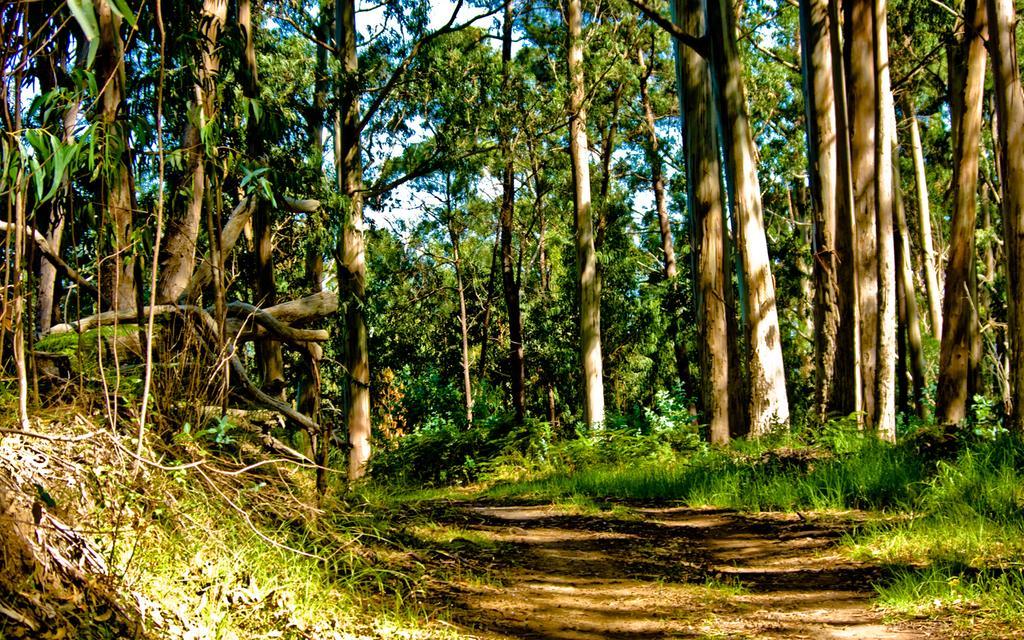Describe this image in one or two sentences. In this image there are trees. At the bottom there is grass. In the background there is sky. 